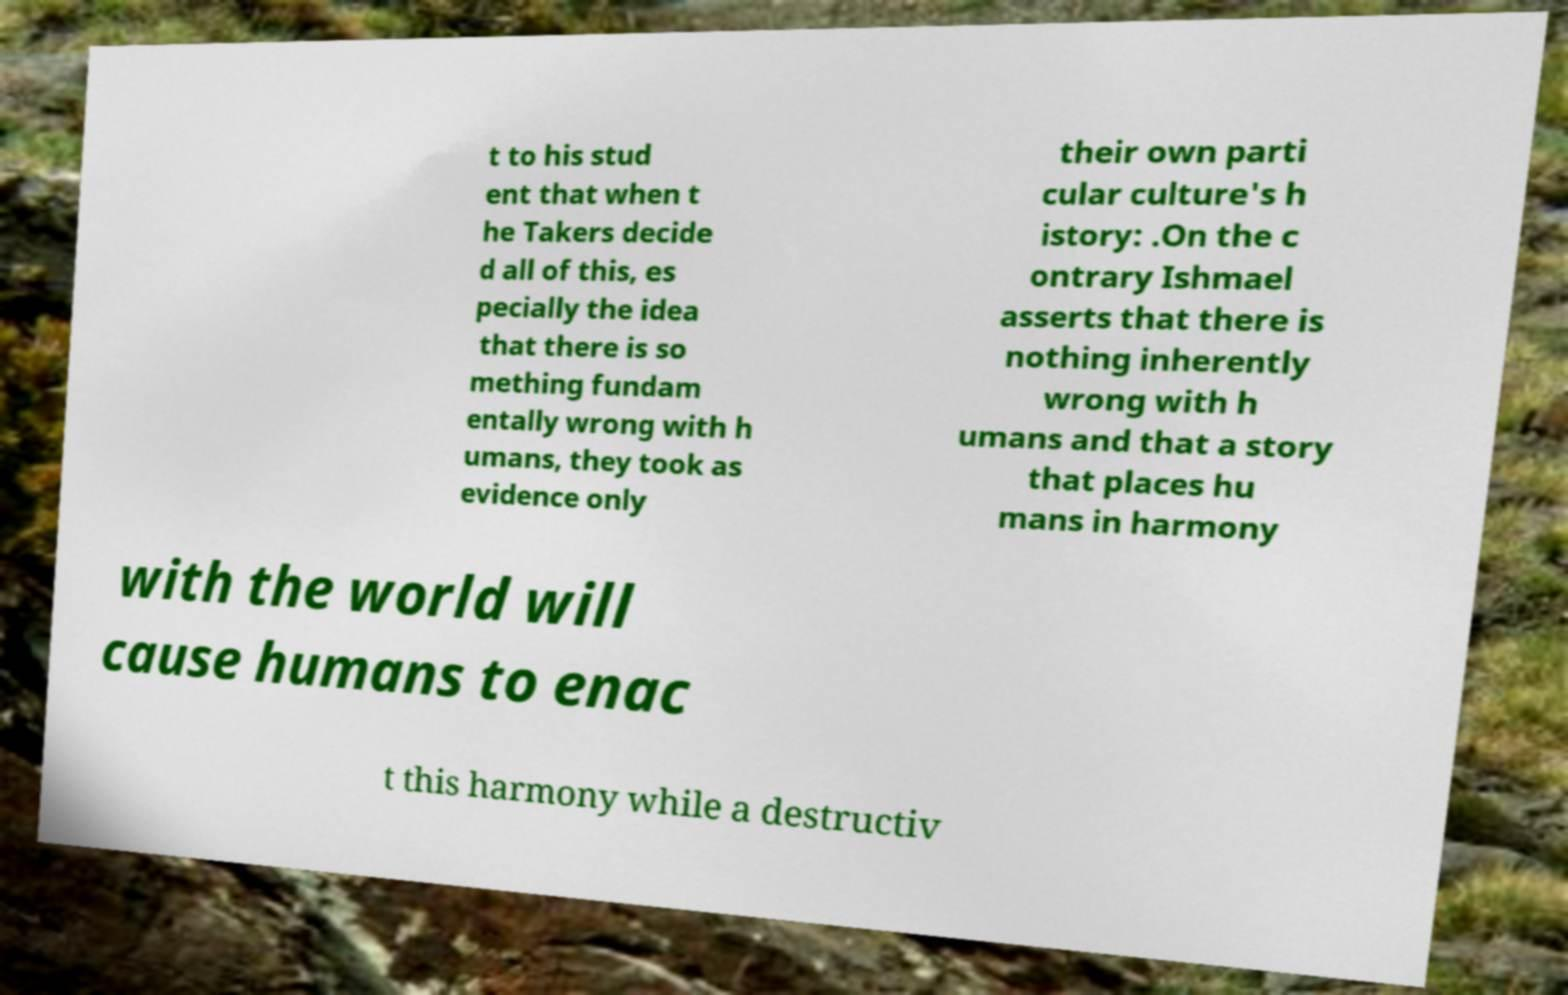Could you assist in decoding the text presented in this image and type it out clearly? t to his stud ent that when t he Takers decide d all of this, es pecially the idea that there is so mething fundam entally wrong with h umans, they took as evidence only their own parti cular culture's h istory: .On the c ontrary Ishmael asserts that there is nothing inherently wrong with h umans and that a story that places hu mans in harmony with the world will cause humans to enac t this harmony while a destructiv 